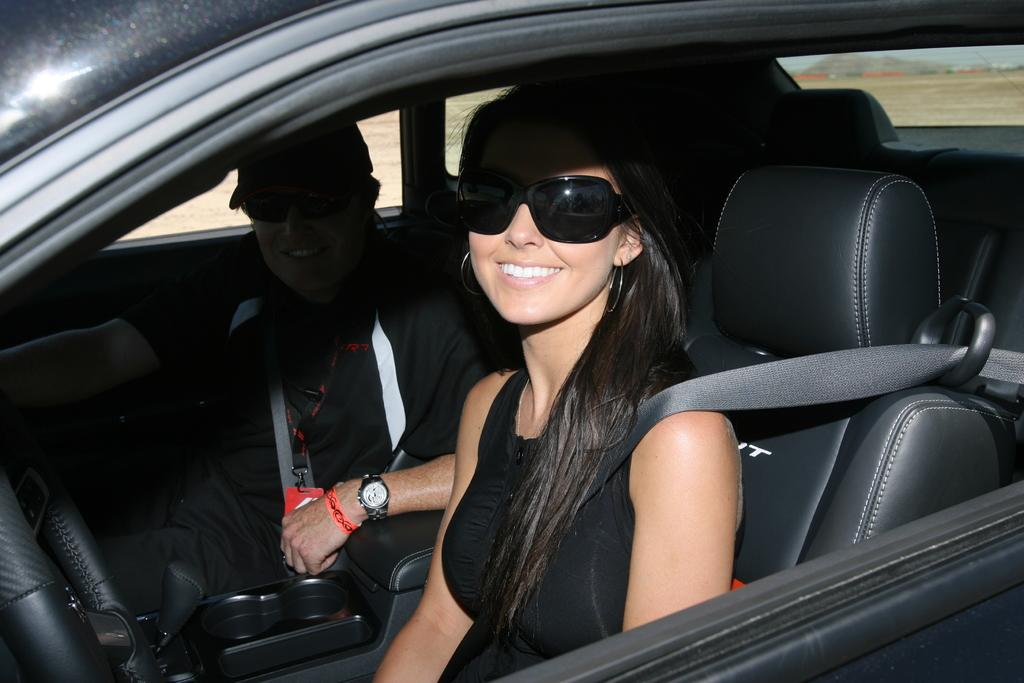How many people are in the car in the image? There are two persons sitting in the car. What safety measures are the persons taking in the image? Both persons are wearing seat belts. What accessories are the persons wearing in the image? Both persons are wearing spectacles. What expressions do the persons have in the image? Both persons are smiling. What can be seen behind the car in the image? There is a background visible in the image, which appears to be a land. What type of branch is the person holding in the image? There is no branch present in the image; it features two persons sitting in a car. What activity is the person doing with their stomach in the image? There is no activity involving a stomach present in the image; both persons are sitting in a car and wearing seat belts. 